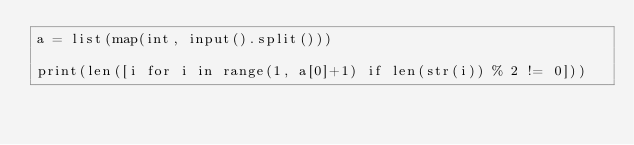Convert code to text. <code><loc_0><loc_0><loc_500><loc_500><_Python_>a = list(map(int, input().split()))

print(len([i for i in range(1, a[0]+1) if len(str(i)) % 2 != 0]))
</code> 